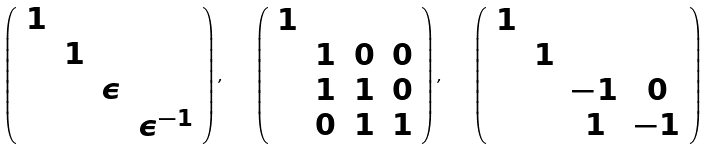<formula> <loc_0><loc_0><loc_500><loc_500>\left ( \begin{array} { c c c c } 1 & & & \\ & 1 & & \\ & & \epsilon & \\ & & & \epsilon ^ { - 1 } \end{array} \right ) , \quad \left ( \begin{array} { c c c c } 1 & & & \\ & 1 & 0 & 0 \\ & 1 & 1 & 0 \\ & 0 & 1 & 1 \end{array} \right ) , \quad \left ( \begin{array} { c c c c } 1 & & & \\ & 1 & & \\ & & - 1 & 0 \\ & & 1 & - 1 \end{array} \right )</formula> 